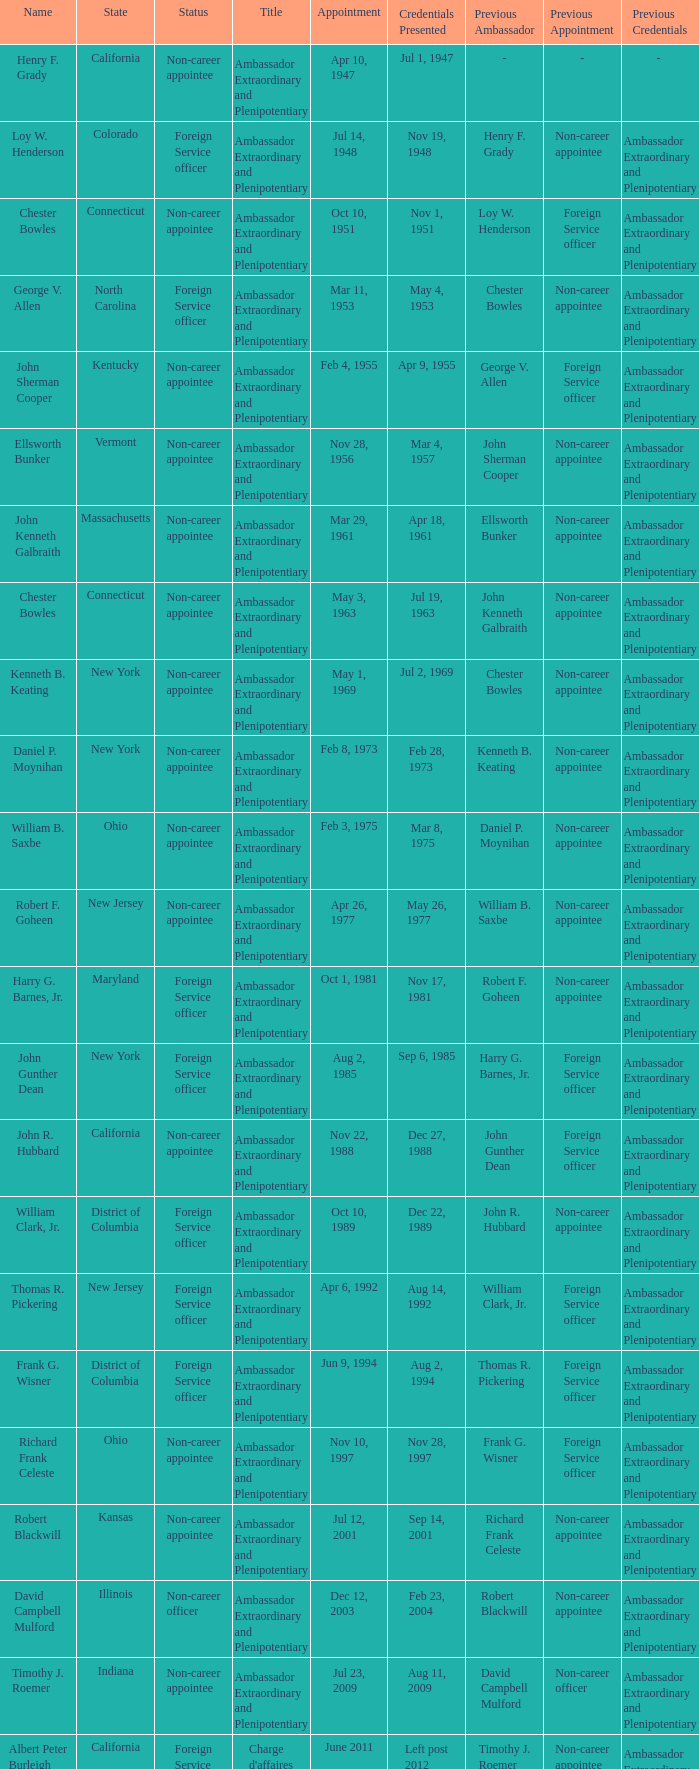What day was the scheduled event when credentials presented took place on jul 2, 1969? May 1, 1969. 